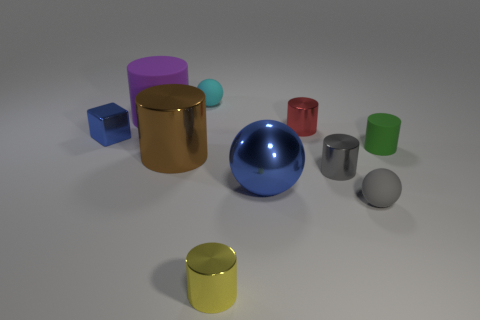Subtract all large blue balls. How many balls are left? 2 Subtract 1 spheres. How many spheres are left? 2 Add 4 tiny cyan matte spheres. How many tiny cyan matte spheres are left? 5 Add 8 big yellow cylinders. How many big yellow cylinders exist? 8 Subtract all brown cylinders. How many cylinders are left? 5 Subtract 0 blue cylinders. How many objects are left? 10 Subtract all balls. How many objects are left? 7 Subtract all green cylinders. Subtract all gray spheres. How many cylinders are left? 5 Subtract all blue balls. How many brown cylinders are left? 1 Subtract all brown metallic things. Subtract all brown shiny cylinders. How many objects are left? 8 